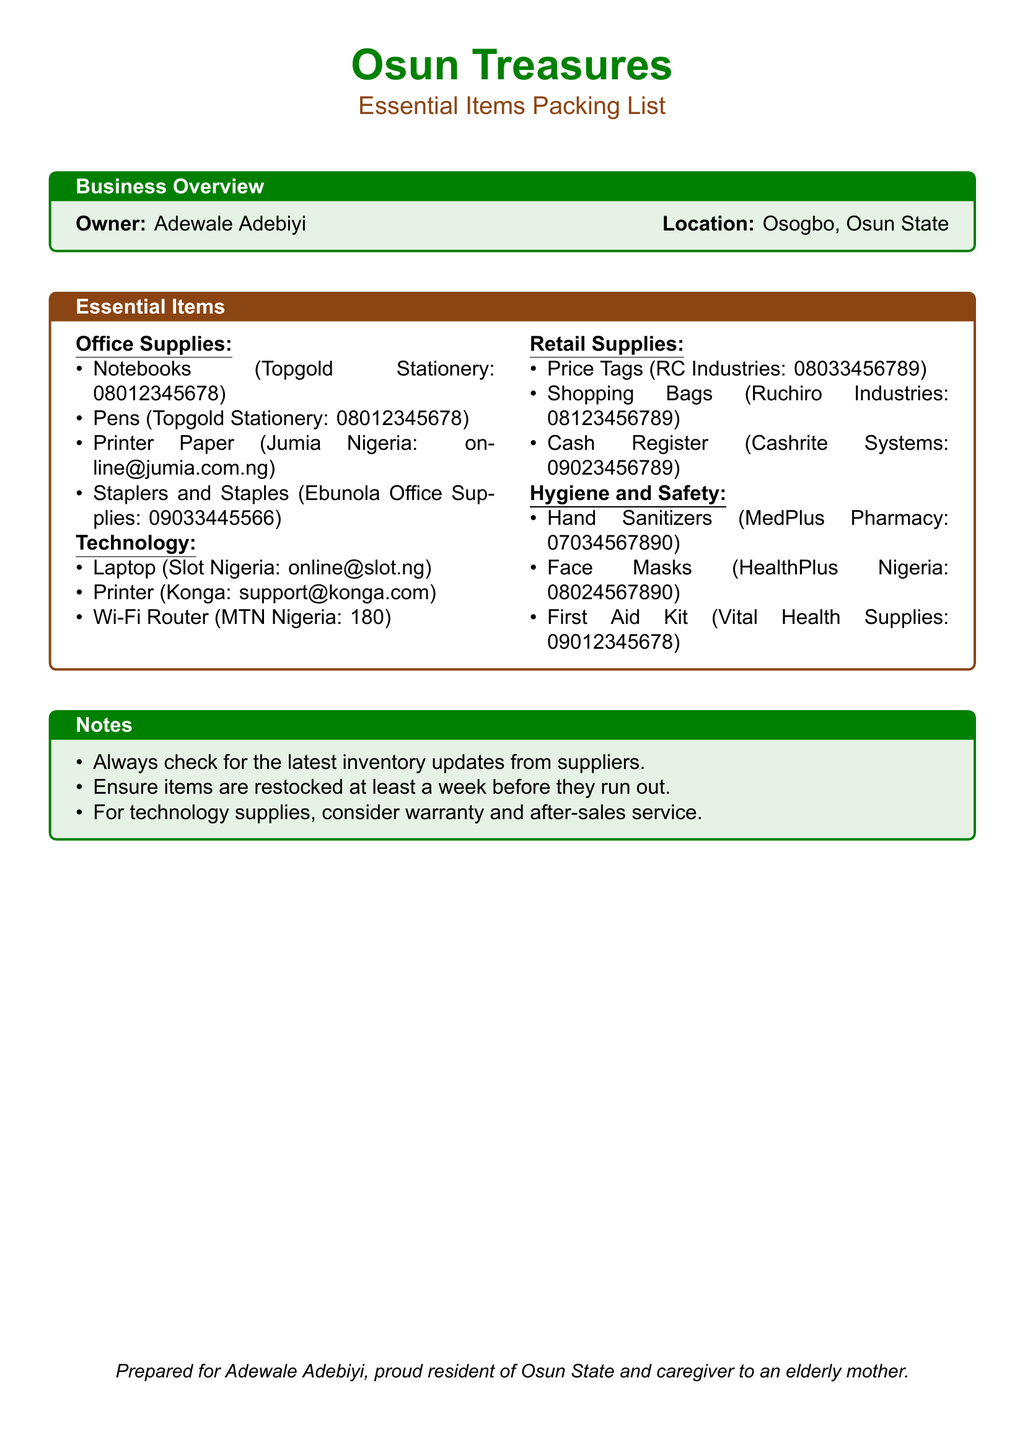What is the owner’s name? The owner's name is mentioned in the business overview section of the document.
Answer: Adewale Adebiyi Which company supplies laptops? The supplier information for technology items includes the company that supplies laptops.
Answer: Slot Nigeria What is the contact number for Topgold Stationery? The contact number for Topgold Stationery is listed under office supplies in the document.
Answer: 08012345678 What type of hygiene item is supplied by MedPlus Pharmacy? The document specifies items under hygiene and safety, including what is supplied by MedPlus Pharmacy.
Answer: Hand Sanitizers What should you check for from suppliers according to the notes? The notes section advises on an important action regarding supplier inventory.
Answer: Latest inventory updates Which item is used for retail and involves pricing? The retail supplies section lists items relevant to retail operations, including price-related items.
Answer: Price Tags What type of item is a Cash Register classified as? The classification of a Cash Register can be found under retail supplies in the document.
Answer: Retail Supplies What is the email contact for Jumia Nigeria? The document provides contact information for suppliers, including email for Jumia Nigeria.
Answer: online@jumia.com.ng 